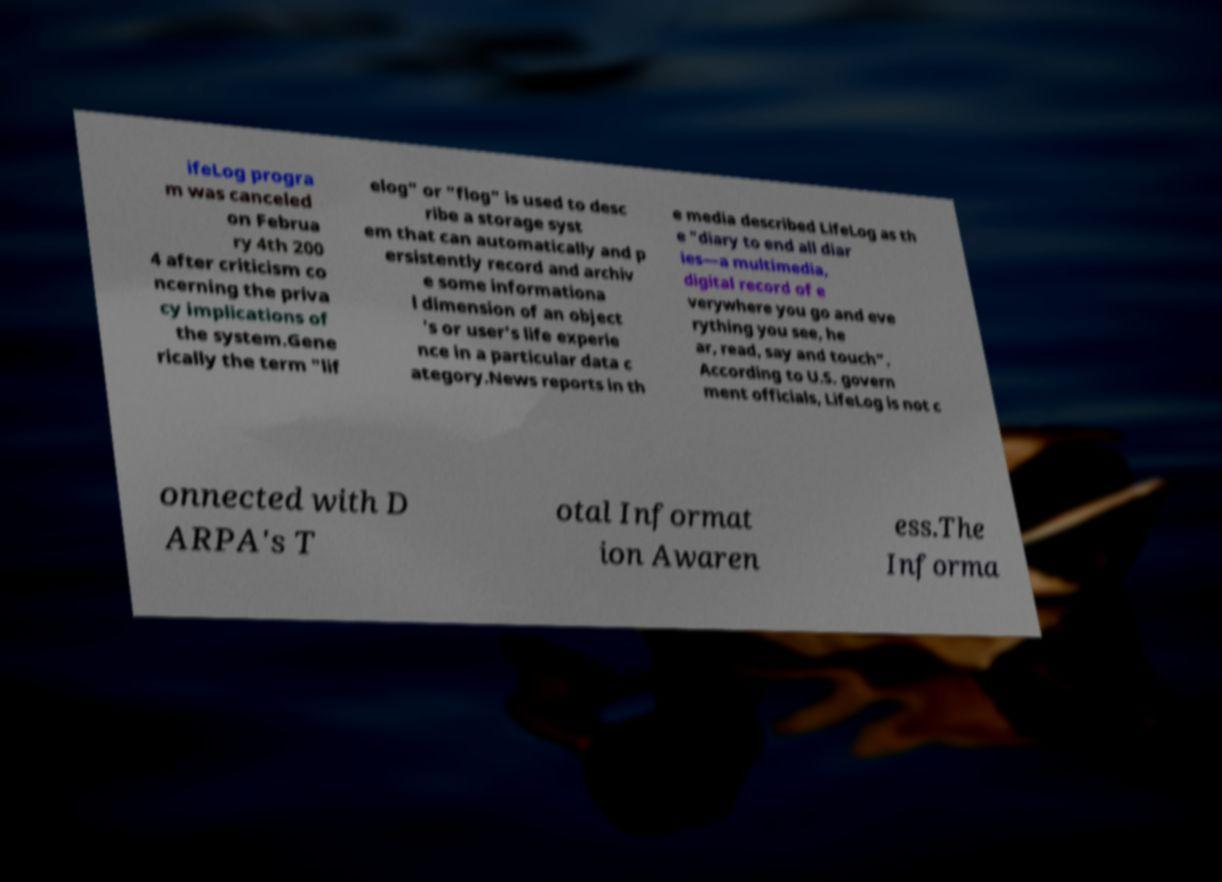There's text embedded in this image that I need extracted. Can you transcribe it verbatim? ifeLog progra m was canceled on Februa ry 4th 200 4 after criticism co ncerning the priva cy implications of the system.Gene rically the term "lif elog" or "flog" is used to desc ribe a storage syst em that can automatically and p ersistently record and archiv e some informationa l dimension of an object 's or user's life experie nce in a particular data c ategory.News reports in th e media described LifeLog as th e "diary to end all diar ies—a multimedia, digital record of e verywhere you go and eve rything you see, he ar, read, say and touch". According to U.S. govern ment officials, LifeLog is not c onnected with D ARPA's T otal Informat ion Awaren ess.The Informa 